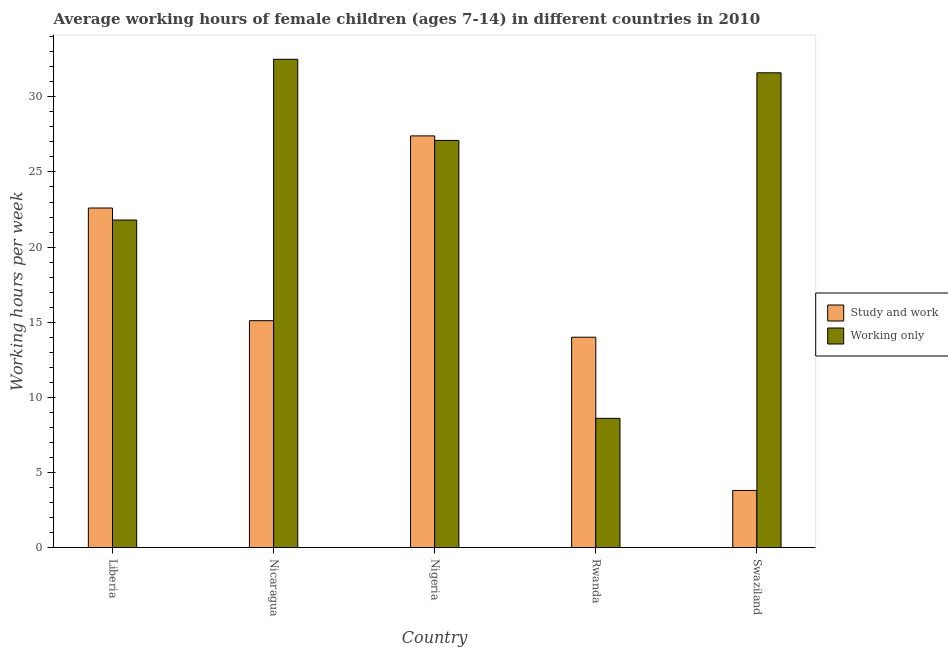How many different coloured bars are there?
Offer a very short reply. 2. How many groups of bars are there?
Your response must be concise. 5. What is the label of the 3rd group of bars from the left?
Provide a succinct answer. Nigeria. In how many cases, is the number of bars for a given country not equal to the number of legend labels?
Provide a short and direct response. 0. What is the average working hour of children involved in only work in Rwanda?
Offer a very short reply. 8.6. Across all countries, what is the maximum average working hour of children involved in study and work?
Your response must be concise. 27.4. Across all countries, what is the minimum average working hour of children involved in study and work?
Offer a terse response. 3.8. In which country was the average working hour of children involved in study and work maximum?
Keep it short and to the point. Nigeria. In which country was the average working hour of children involved in only work minimum?
Offer a very short reply. Rwanda. What is the total average working hour of children involved in only work in the graph?
Ensure brevity in your answer.  121.6. What is the difference between the average working hour of children involved in only work in Liberia and that in Nicaragua?
Ensure brevity in your answer.  -10.7. What is the average average working hour of children involved in study and work per country?
Keep it short and to the point. 16.58. What is the difference between the average working hour of children involved in only work and average working hour of children involved in study and work in Liberia?
Offer a very short reply. -0.8. In how many countries, is the average working hour of children involved in study and work greater than 27 hours?
Make the answer very short. 1. What is the ratio of the average working hour of children involved in only work in Liberia to that in Nicaragua?
Your response must be concise. 0.67. Is the difference between the average working hour of children involved in only work in Liberia and Nigeria greater than the difference between the average working hour of children involved in study and work in Liberia and Nigeria?
Offer a terse response. No. What is the difference between the highest and the second highest average working hour of children involved in only work?
Your response must be concise. 0.9. What is the difference between the highest and the lowest average working hour of children involved in study and work?
Provide a succinct answer. 23.6. In how many countries, is the average working hour of children involved in only work greater than the average average working hour of children involved in only work taken over all countries?
Ensure brevity in your answer.  3. What does the 2nd bar from the left in Nicaragua represents?
Provide a short and direct response. Working only. What does the 1st bar from the right in Nigeria represents?
Ensure brevity in your answer.  Working only. What is the difference between two consecutive major ticks on the Y-axis?
Provide a succinct answer. 5. Does the graph contain grids?
Make the answer very short. No. What is the title of the graph?
Offer a very short reply. Average working hours of female children (ages 7-14) in different countries in 2010. What is the label or title of the Y-axis?
Offer a very short reply. Working hours per week. What is the Working hours per week in Study and work in Liberia?
Offer a very short reply. 22.6. What is the Working hours per week in Working only in Liberia?
Your response must be concise. 21.8. What is the Working hours per week of Study and work in Nicaragua?
Provide a short and direct response. 15.1. What is the Working hours per week in Working only in Nicaragua?
Your answer should be compact. 32.5. What is the Working hours per week of Study and work in Nigeria?
Your response must be concise. 27.4. What is the Working hours per week of Working only in Nigeria?
Ensure brevity in your answer.  27.1. What is the Working hours per week of Study and work in Rwanda?
Your response must be concise. 14. What is the Working hours per week of Working only in Rwanda?
Your answer should be very brief. 8.6. What is the Working hours per week in Study and work in Swaziland?
Your answer should be very brief. 3.8. What is the Working hours per week in Working only in Swaziland?
Your answer should be compact. 31.6. Across all countries, what is the maximum Working hours per week of Study and work?
Your response must be concise. 27.4. Across all countries, what is the maximum Working hours per week of Working only?
Ensure brevity in your answer.  32.5. What is the total Working hours per week in Study and work in the graph?
Ensure brevity in your answer.  82.9. What is the total Working hours per week of Working only in the graph?
Ensure brevity in your answer.  121.6. What is the difference between the Working hours per week in Study and work in Liberia and that in Nigeria?
Offer a very short reply. -4.8. What is the difference between the Working hours per week in Working only in Liberia and that in Nigeria?
Keep it short and to the point. -5.3. What is the difference between the Working hours per week in Study and work in Liberia and that in Swaziland?
Your answer should be very brief. 18.8. What is the difference between the Working hours per week of Study and work in Nicaragua and that in Nigeria?
Keep it short and to the point. -12.3. What is the difference between the Working hours per week of Working only in Nicaragua and that in Rwanda?
Keep it short and to the point. 23.9. What is the difference between the Working hours per week of Study and work in Nicaragua and that in Swaziland?
Offer a terse response. 11.3. What is the difference between the Working hours per week of Working only in Nicaragua and that in Swaziland?
Offer a very short reply. 0.9. What is the difference between the Working hours per week in Study and work in Nigeria and that in Swaziland?
Your response must be concise. 23.6. What is the difference between the Working hours per week of Study and work in Liberia and the Working hours per week of Working only in Nicaragua?
Make the answer very short. -9.9. What is the difference between the Working hours per week in Study and work in Liberia and the Working hours per week in Working only in Nigeria?
Make the answer very short. -4.5. What is the difference between the Working hours per week of Study and work in Liberia and the Working hours per week of Working only in Swaziland?
Your response must be concise. -9. What is the difference between the Working hours per week in Study and work in Nicaragua and the Working hours per week in Working only in Nigeria?
Keep it short and to the point. -12. What is the difference between the Working hours per week of Study and work in Nicaragua and the Working hours per week of Working only in Swaziland?
Your answer should be compact. -16.5. What is the difference between the Working hours per week of Study and work in Nigeria and the Working hours per week of Working only in Rwanda?
Offer a very short reply. 18.8. What is the difference between the Working hours per week in Study and work in Nigeria and the Working hours per week in Working only in Swaziland?
Keep it short and to the point. -4.2. What is the difference between the Working hours per week in Study and work in Rwanda and the Working hours per week in Working only in Swaziland?
Your response must be concise. -17.6. What is the average Working hours per week of Study and work per country?
Give a very brief answer. 16.58. What is the average Working hours per week in Working only per country?
Your answer should be compact. 24.32. What is the difference between the Working hours per week in Study and work and Working hours per week in Working only in Nicaragua?
Your response must be concise. -17.4. What is the difference between the Working hours per week in Study and work and Working hours per week in Working only in Nigeria?
Give a very brief answer. 0.3. What is the difference between the Working hours per week of Study and work and Working hours per week of Working only in Rwanda?
Provide a succinct answer. 5.4. What is the difference between the Working hours per week in Study and work and Working hours per week in Working only in Swaziland?
Your response must be concise. -27.8. What is the ratio of the Working hours per week of Study and work in Liberia to that in Nicaragua?
Give a very brief answer. 1.5. What is the ratio of the Working hours per week in Working only in Liberia to that in Nicaragua?
Provide a succinct answer. 0.67. What is the ratio of the Working hours per week of Study and work in Liberia to that in Nigeria?
Give a very brief answer. 0.82. What is the ratio of the Working hours per week in Working only in Liberia to that in Nigeria?
Offer a terse response. 0.8. What is the ratio of the Working hours per week of Study and work in Liberia to that in Rwanda?
Offer a very short reply. 1.61. What is the ratio of the Working hours per week of Working only in Liberia to that in Rwanda?
Ensure brevity in your answer.  2.53. What is the ratio of the Working hours per week of Study and work in Liberia to that in Swaziland?
Provide a succinct answer. 5.95. What is the ratio of the Working hours per week of Working only in Liberia to that in Swaziland?
Keep it short and to the point. 0.69. What is the ratio of the Working hours per week in Study and work in Nicaragua to that in Nigeria?
Your response must be concise. 0.55. What is the ratio of the Working hours per week of Working only in Nicaragua to that in Nigeria?
Offer a very short reply. 1.2. What is the ratio of the Working hours per week of Study and work in Nicaragua to that in Rwanda?
Make the answer very short. 1.08. What is the ratio of the Working hours per week of Working only in Nicaragua to that in Rwanda?
Your response must be concise. 3.78. What is the ratio of the Working hours per week in Study and work in Nicaragua to that in Swaziland?
Your response must be concise. 3.97. What is the ratio of the Working hours per week in Working only in Nicaragua to that in Swaziland?
Provide a short and direct response. 1.03. What is the ratio of the Working hours per week of Study and work in Nigeria to that in Rwanda?
Your response must be concise. 1.96. What is the ratio of the Working hours per week in Working only in Nigeria to that in Rwanda?
Your answer should be compact. 3.15. What is the ratio of the Working hours per week of Study and work in Nigeria to that in Swaziland?
Your answer should be compact. 7.21. What is the ratio of the Working hours per week in Working only in Nigeria to that in Swaziland?
Make the answer very short. 0.86. What is the ratio of the Working hours per week of Study and work in Rwanda to that in Swaziland?
Offer a terse response. 3.68. What is the ratio of the Working hours per week in Working only in Rwanda to that in Swaziland?
Keep it short and to the point. 0.27. What is the difference between the highest and the second highest Working hours per week of Study and work?
Keep it short and to the point. 4.8. What is the difference between the highest and the second highest Working hours per week in Working only?
Keep it short and to the point. 0.9. What is the difference between the highest and the lowest Working hours per week of Study and work?
Provide a short and direct response. 23.6. What is the difference between the highest and the lowest Working hours per week of Working only?
Give a very brief answer. 23.9. 